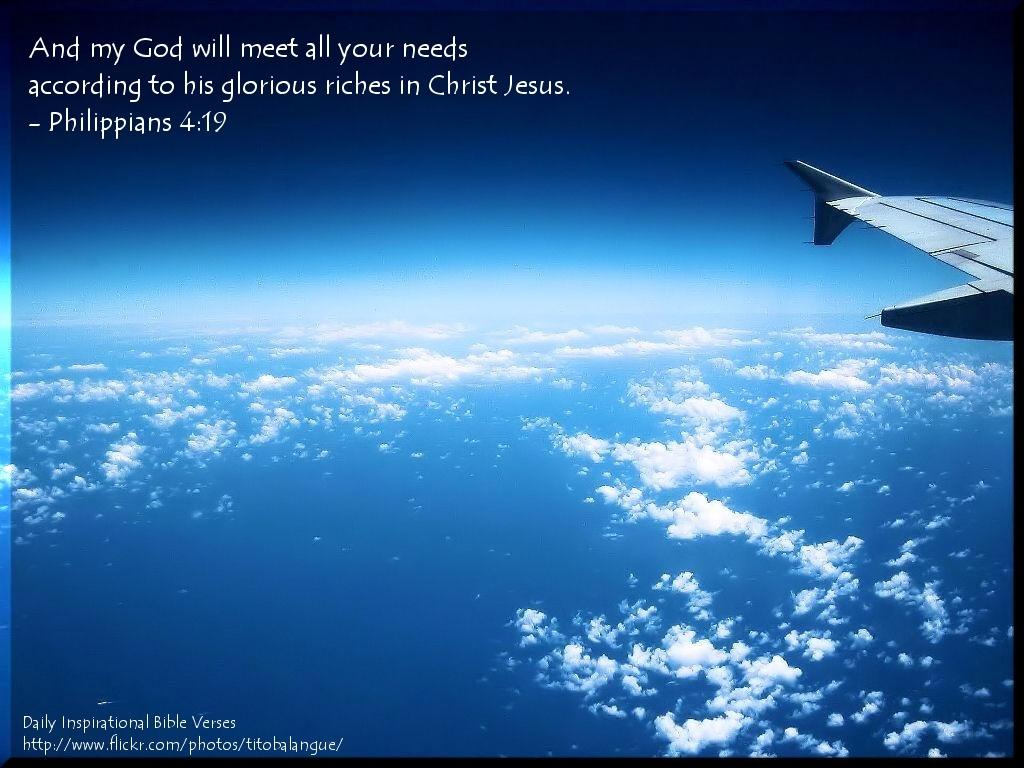<image>
Summarize the visual content of the image. A quote about Jesus is written on a picture of the sky. 